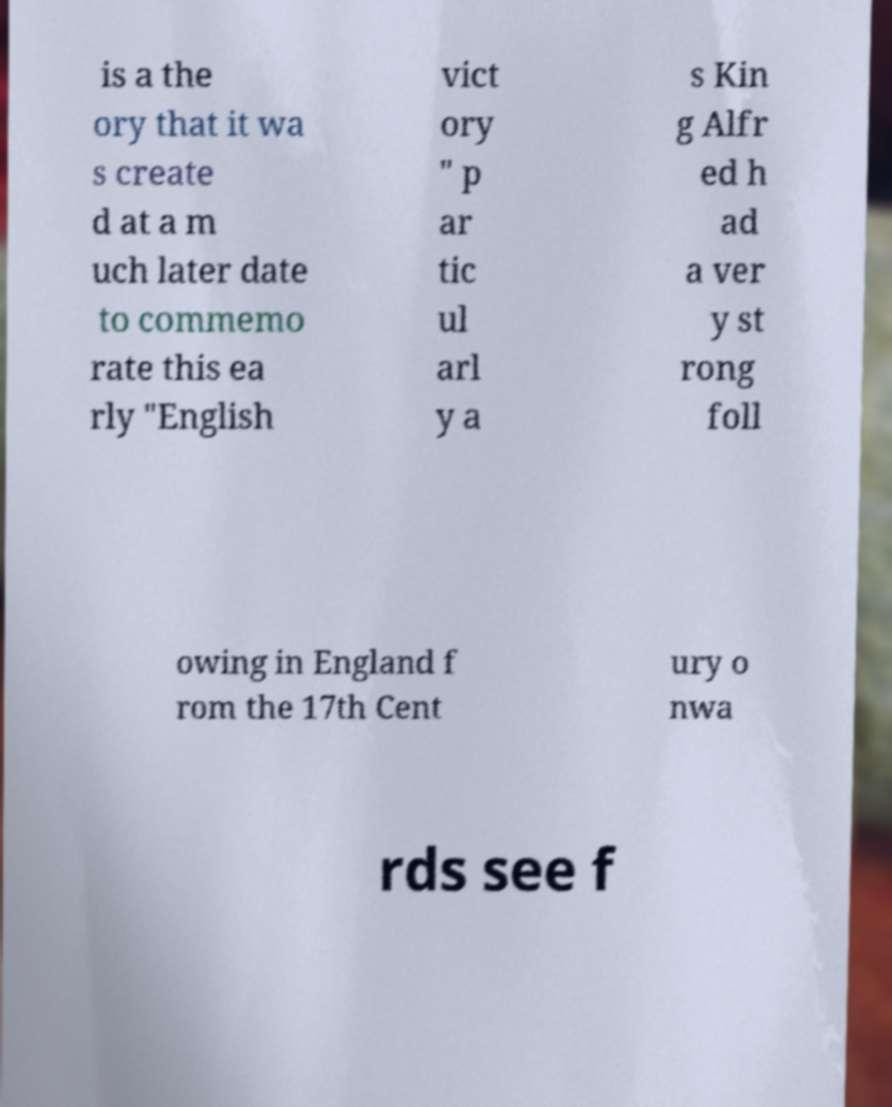What messages or text are displayed in this image? I need them in a readable, typed format. is a the ory that it wa s create d at a m uch later date to commemo rate this ea rly "English vict ory " p ar tic ul arl y a s Kin g Alfr ed h ad a ver y st rong foll owing in England f rom the 17th Cent ury o nwa rds see f 